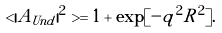Convert formula to latex. <formula><loc_0><loc_0><loc_500><loc_500>< | A _ { U n d } | ^ { 2 } > = 1 + \exp [ - { q } ^ { 2 } R ^ { 2 } ] .</formula> 